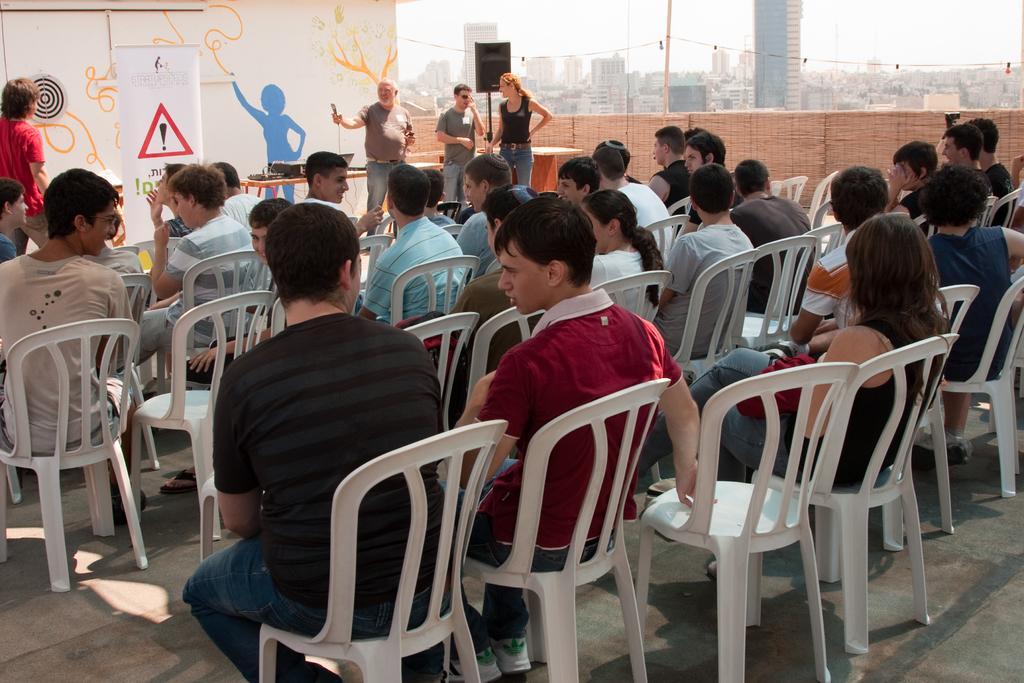How would you summarize this image in a sentence or two? There are few chairs in the image. On the chairs people are sitting. In front of them few people are standing. This person is holding a mic. There is banner. There is a speaker over here. There is boundary around the floor. In the background there are buildings. 